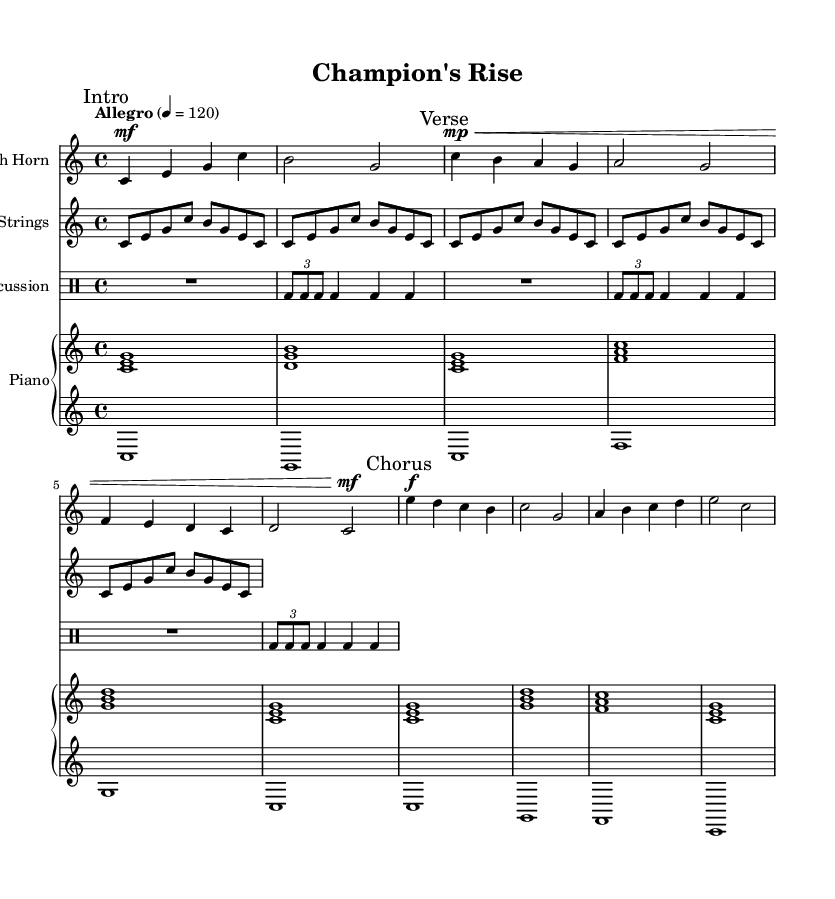What is the key signature of this music? The key signature is C major, which has no sharps or flats.
Answer: C major What is the time signature of this piece? The time signature is indicated as 4/4, meaning there are four beats in each measure.
Answer: 4/4 What is the tempo marking for this piece? The piece is marked as Allegro with a tempo of 120 beats per minute, which indicates a fast and lively tempo.
Answer: Allegro How many measures are in the Chorus section? The Chorus section consists of four measures, as indicated by the notation following the "Chorus" mark.
Answer: 4 What instruments are featured in this composition? The score includes a French Horn, Strings, Percussion, and Piano, as indicated by the respective staff labels.
Answer: French Horn, Strings, Percussion, Piano In which section does the French Horn play a staccato marking? The French Horn does not have any staccato markings throughout the piece; all notes are represented with standard articulations.
Answer: None 